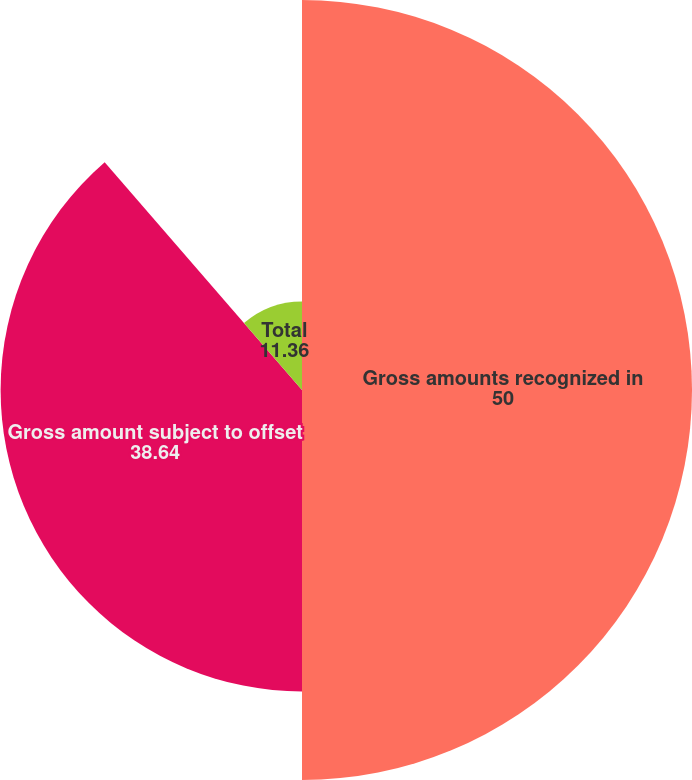Convert chart to OTSL. <chart><loc_0><loc_0><loc_500><loc_500><pie_chart><fcel>Gross amounts recognized in<fcel>Gross amount subject to offset<fcel>Total<nl><fcel>50.0%<fcel>38.64%<fcel>11.36%<nl></chart> 